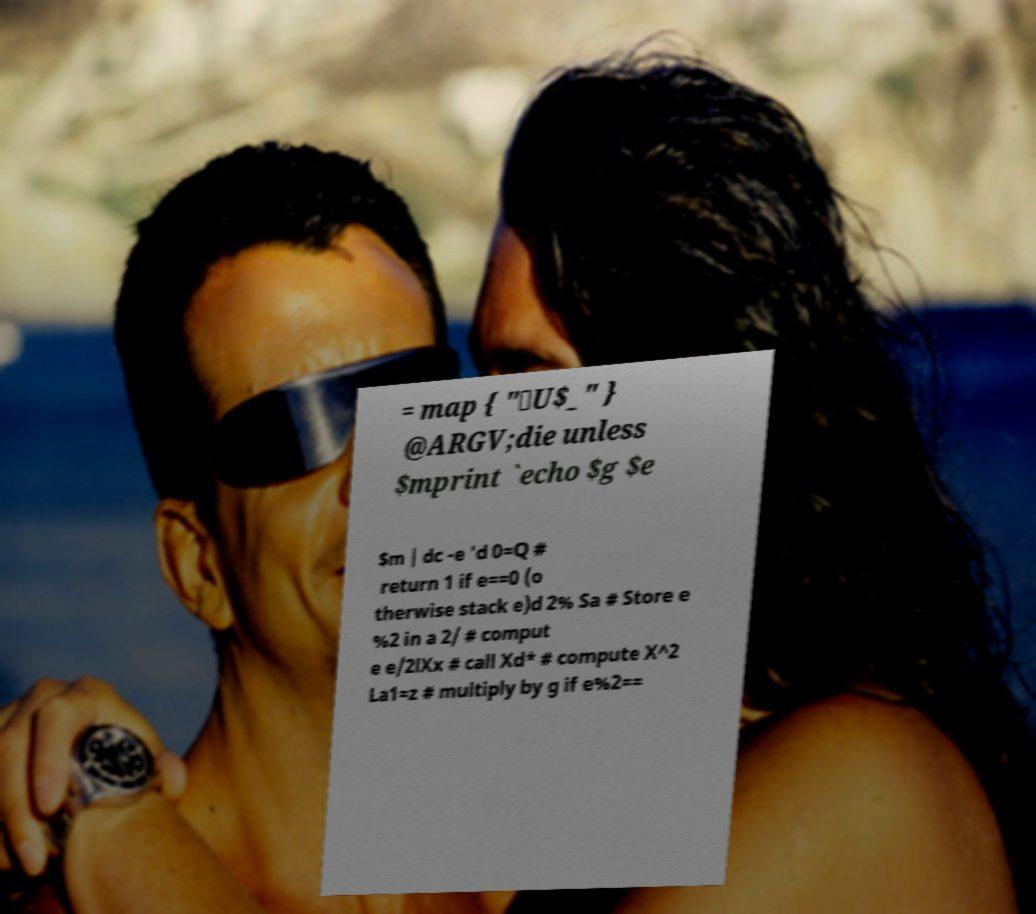I need the written content from this picture converted into text. Can you do that? = map { "\U$_" } @ARGV;die unless $mprint `echo $g $e $m | dc -e 'd 0=Q # return 1 if e==0 (o therwise stack e)d 2% Sa # Store e %2 in a 2/ # comput e e/2lXx # call Xd* # compute X^2 La1=z # multiply by g if e%2== 